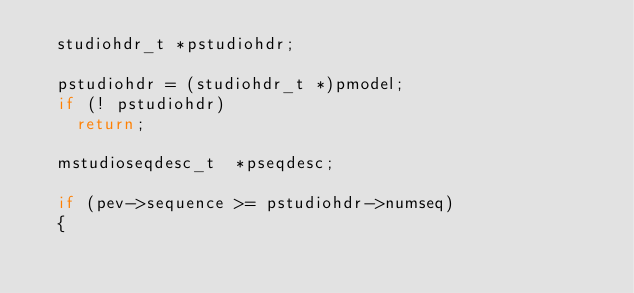Convert code to text. <code><loc_0><loc_0><loc_500><loc_500><_C++_>	studiohdr_t *pstudiohdr;
	
	pstudiohdr = (studiohdr_t *)pmodel;
	if (! pstudiohdr)
		return;

	mstudioseqdesc_t	*pseqdesc;

	if (pev->sequence >= pstudiohdr->numseq)
	{</code> 